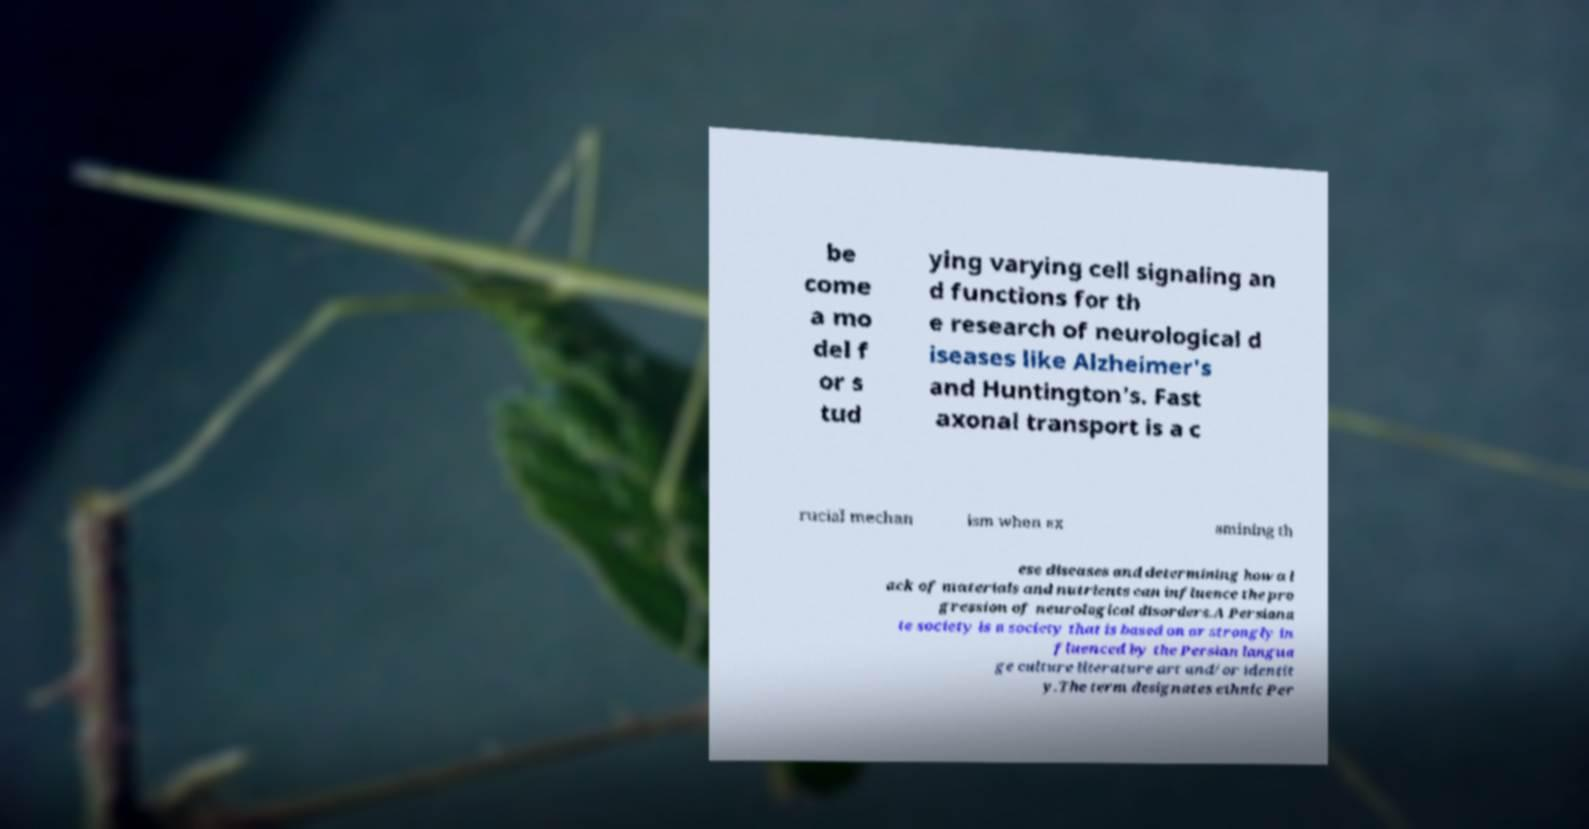Please read and relay the text visible in this image. What does it say? be come a mo del f or s tud ying varying cell signaling an d functions for th e research of neurological d iseases like Alzheimer's and Huntington's. Fast axonal transport is a c rucial mechan ism when ex amining th ese diseases and determining how a l ack of materials and nutrients can influence the pro gression of neurological disorders.A Persiana te society is a society that is based on or strongly in fluenced by the Persian langua ge culture literature art and/or identit y.The term designates ethnic Per 